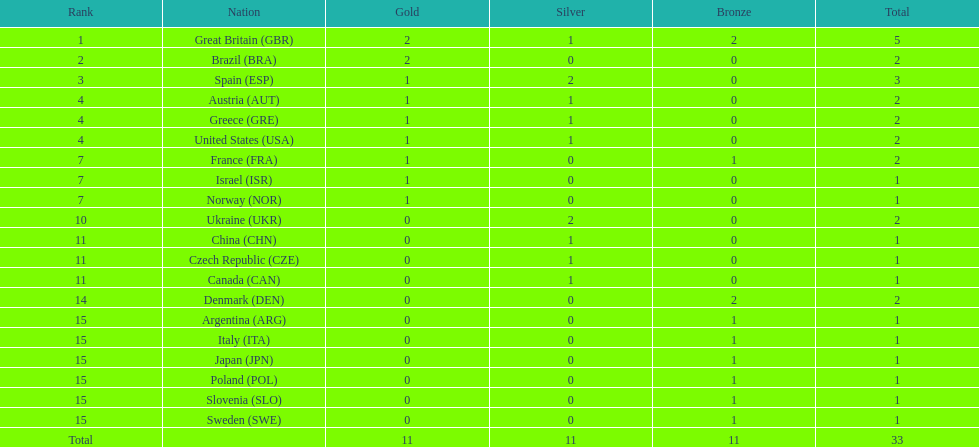What was the total number of medals won by united states? 2. 